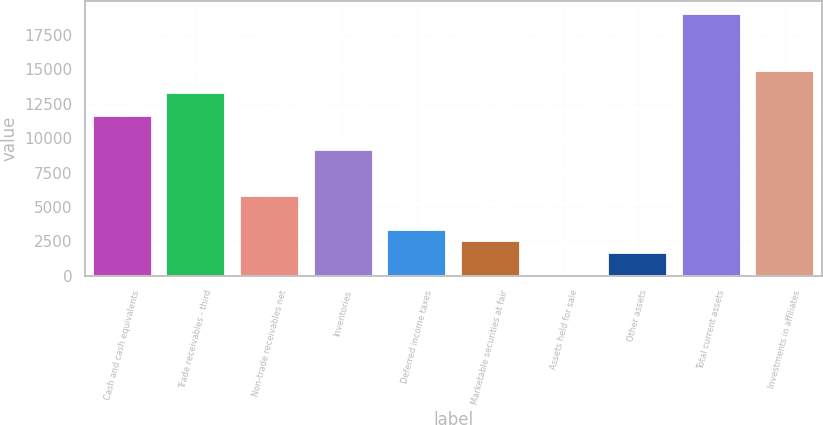Convert chart. <chart><loc_0><loc_0><loc_500><loc_500><bar_chart><fcel>Cash and cash equivalents<fcel>Trade receivables - third<fcel>Non-trade receivables net<fcel>Inventories<fcel>Deferred income taxes<fcel>Marketable securities at fair<fcel>Assets held for sale<fcel>Other assets<fcel>Total current assets<fcel>Investments in affiliates<nl><fcel>11589.8<fcel>13244.2<fcel>5799.4<fcel>9108.2<fcel>3317.8<fcel>2490.6<fcel>9<fcel>1663.4<fcel>19034.6<fcel>14898.6<nl></chart> 